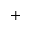Convert formula to latex. <formula><loc_0><loc_0><loc_500><loc_500>+</formula> 